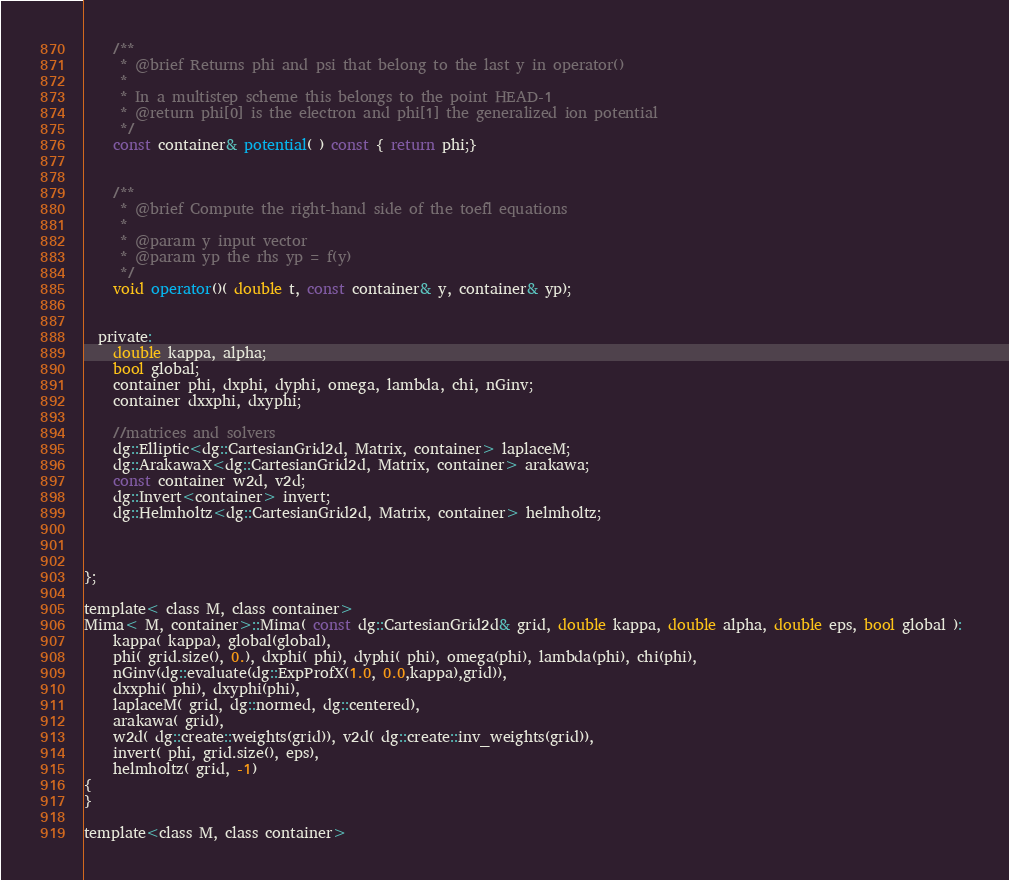Convert code to text. <code><loc_0><loc_0><loc_500><loc_500><_Cuda_>    /**
     * @brief Returns phi and psi that belong to the last y in operator()
     *
     * In a multistep scheme this belongs to the point HEAD-1
     * @return phi[0] is the electron and phi[1] the generalized ion potential
     */
    const container& potential( ) const { return phi;}


    /**
     * @brief Compute the right-hand side of the toefl equations
     *
     * @param y input vector
     * @param yp the rhs yp = f(y)
     */
    void operator()( double t, const container& y, container& yp);


  private:
    double kappa, alpha;
    bool global;
    container phi, dxphi, dyphi, omega, lambda, chi, nGinv;
    container dxxphi, dxyphi;

    //matrices and solvers
    dg::Elliptic<dg::CartesianGrid2d, Matrix, container> laplaceM;
    dg::ArakawaX<dg::CartesianGrid2d, Matrix, container> arakawa; 
    const container w2d, v2d;
    dg::Invert<container> invert;
    dg::Helmholtz<dg::CartesianGrid2d, Matrix, container> helmholtz;



};

template< class M, class container>
Mima< M, container>::Mima( const dg::CartesianGrid2d& grid, double kappa, double alpha, double eps, bool global ): 
    kappa( kappa), global(global),
    phi( grid.size(), 0.), dxphi( phi), dyphi( phi), omega(phi), lambda(phi), chi(phi),
    nGinv(dg::evaluate(dg::ExpProfX(1.0, 0.0,kappa),grid)),
    dxxphi( phi), dxyphi(phi),
    laplaceM( grid, dg::normed, dg::centered),
    arakawa( grid), 
    w2d( dg::create::weights(grid)), v2d( dg::create::inv_weights(grid)),
    invert( phi, grid.size(), eps),
    helmholtz( grid, -1)
{
}

template<class M, class container></code> 